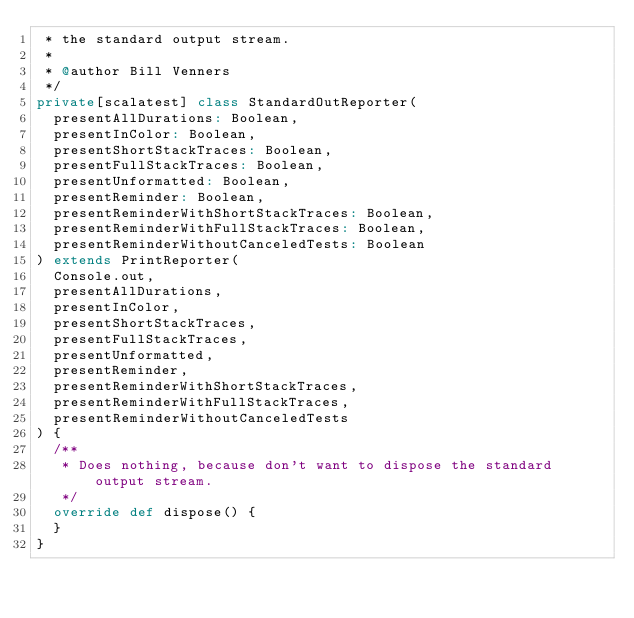Convert code to text. <code><loc_0><loc_0><loc_500><loc_500><_Scala_> * the standard output stream.
 *
 * @author Bill Venners
 */
private[scalatest] class StandardOutReporter(
  presentAllDurations: Boolean,
  presentInColor: Boolean,
  presentShortStackTraces: Boolean,
  presentFullStackTraces: Boolean,
  presentUnformatted: Boolean,
  presentReminder: Boolean,
  presentReminderWithShortStackTraces: Boolean,
  presentReminderWithFullStackTraces: Boolean,
  presentReminderWithoutCanceledTests: Boolean
) extends PrintReporter(
  Console.out,
  presentAllDurations,
  presentInColor,
  presentShortStackTraces,
  presentFullStackTraces,
  presentUnformatted,
  presentReminder,
  presentReminderWithShortStackTraces,
  presentReminderWithFullStackTraces,
  presentReminderWithoutCanceledTests
) {
  /**
   * Does nothing, because don't want to dispose the standard output stream.
   */
  override def dispose() {
  }
}
</code> 